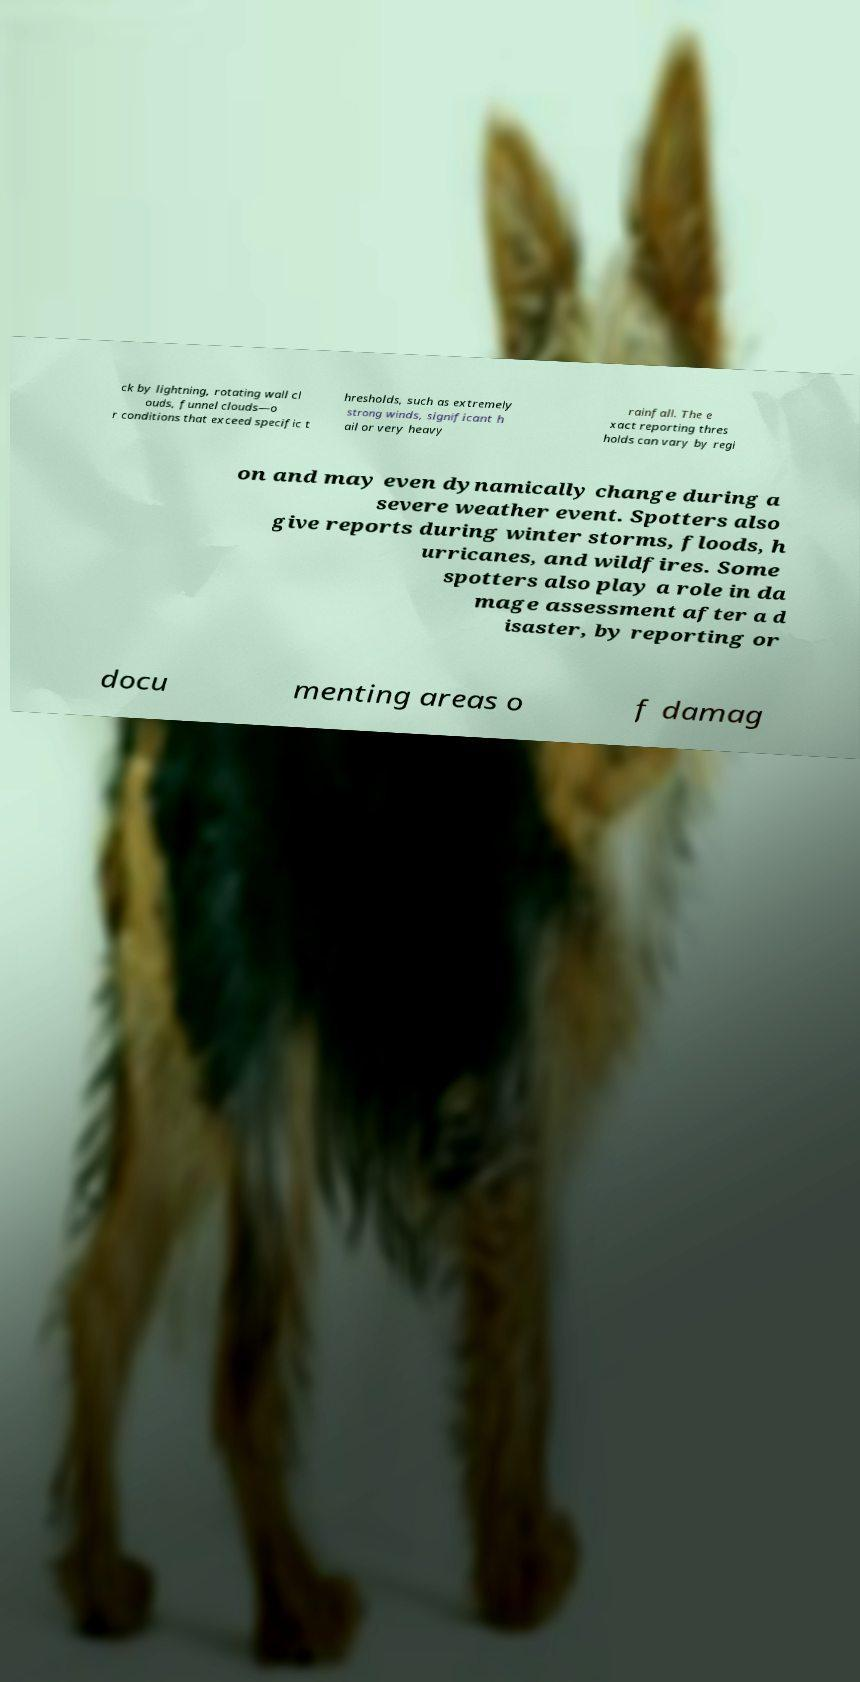Please read and relay the text visible in this image. What does it say? ck by lightning, rotating wall cl ouds, funnel clouds—o r conditions that exceed specific t hresholds, such as extremely strong winds, significant h ail or very heavy rainfall. The e xact reporting thres holds can vary by regi on and may even dynamically change during a severe weather event. Spotters also give reports during winter storms, floods, h urricanes, and wildfires. Some spotters also play a role in da mage assessment after a d isaster, by reporting or docu menting areas o f damag 